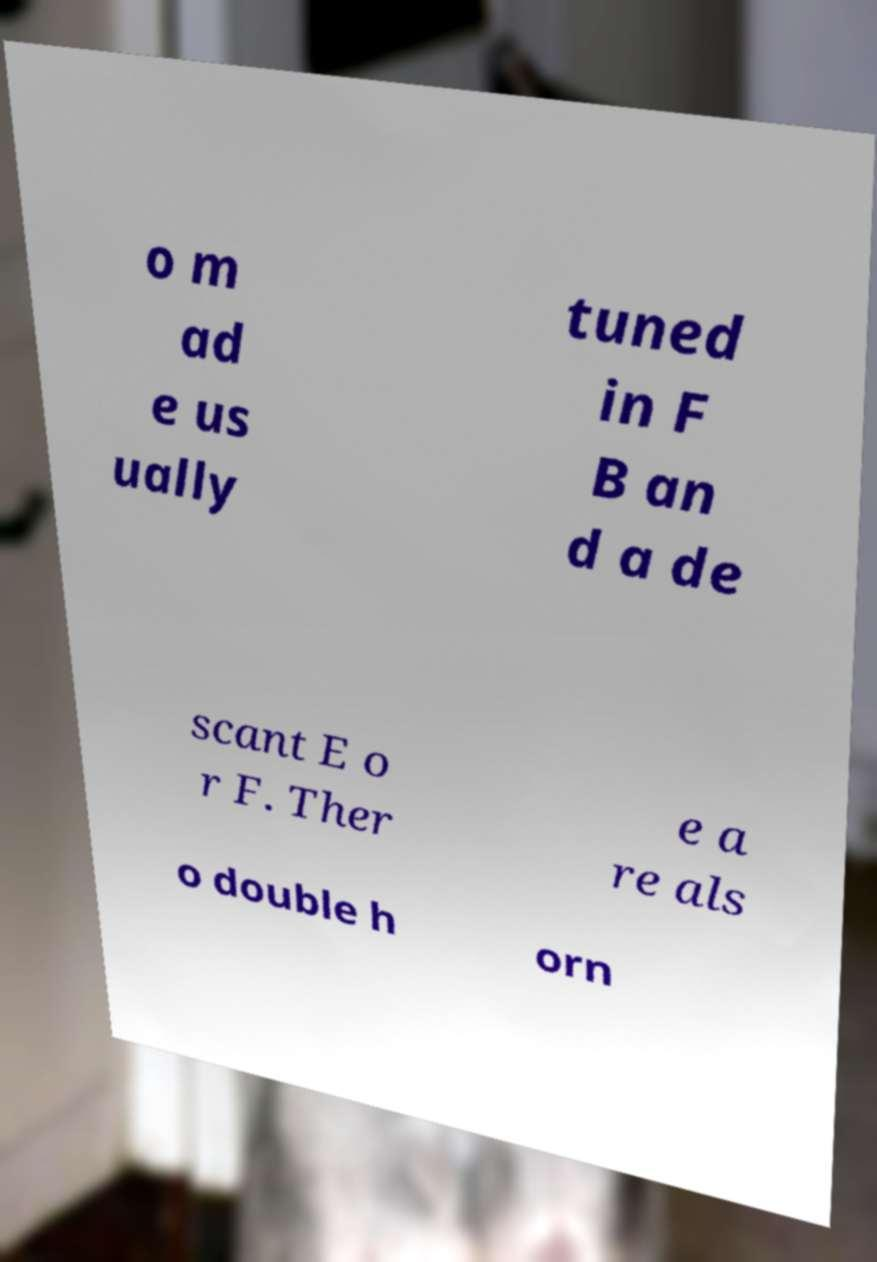Could you extract and type out the text from this image? o m ad e us ually tuned in F B an d a de scant E o r F. Ther e a re als o double h orn 